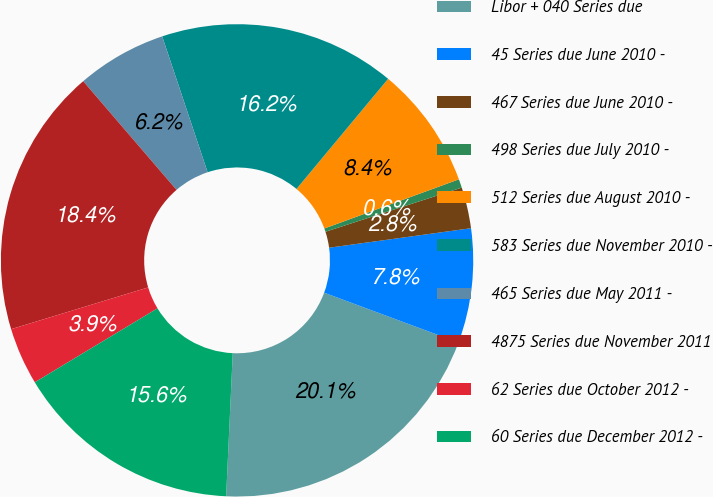Convert chart. <chart><loc_0><loc_0><loc_500><loc_500><pie_chart><fcel>Libor + 040 Series due<fcel>45 Series due June 2010 -<fcel>467 Series due June 2010 -<fcel>498 Series due July 2010 -<fcel>512 Series due August 2010 -<fcel>583 Series due November 2010 -<fcel>465 Series due May 2011 -<fcel>4875 Series due November 2011<fcel>62 Series due October 2012 -<fcel>60 Series due December 2012 -<nl><fcel>20.08%<fcel>7.83%<fcel>2.81%<fcel>0.59%<fcel>8.38%<fcel>16.18%<fcel>6.16%<fcel>18.41%<fcel>3.93%<fcel>15.63%<nl></chart> 